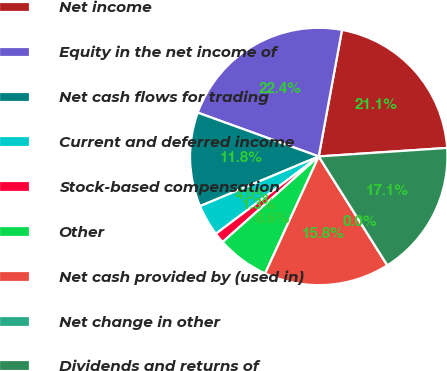<chart> <loc_0><loc_0><loc_500><loc_500><pie_chart><fcel>Net income<fcel>Equity in the net income of<fcel>Net cash flows for trading<fcel>Current and deferred income<fcel>Stock-based compensation<fcel>Other<fcel>Net cash provided by (used in)<fcel>Net change in other<fcel>Dividends and returns of<nl><fcel>21.05%<fcel>22.36%<fcel>11.84%<fcel>3.95%<fcel>1.32%<fcel>6.58%<fcel>15.79%<fcel>0.0%<fcel>17.1%<nl></chart> 